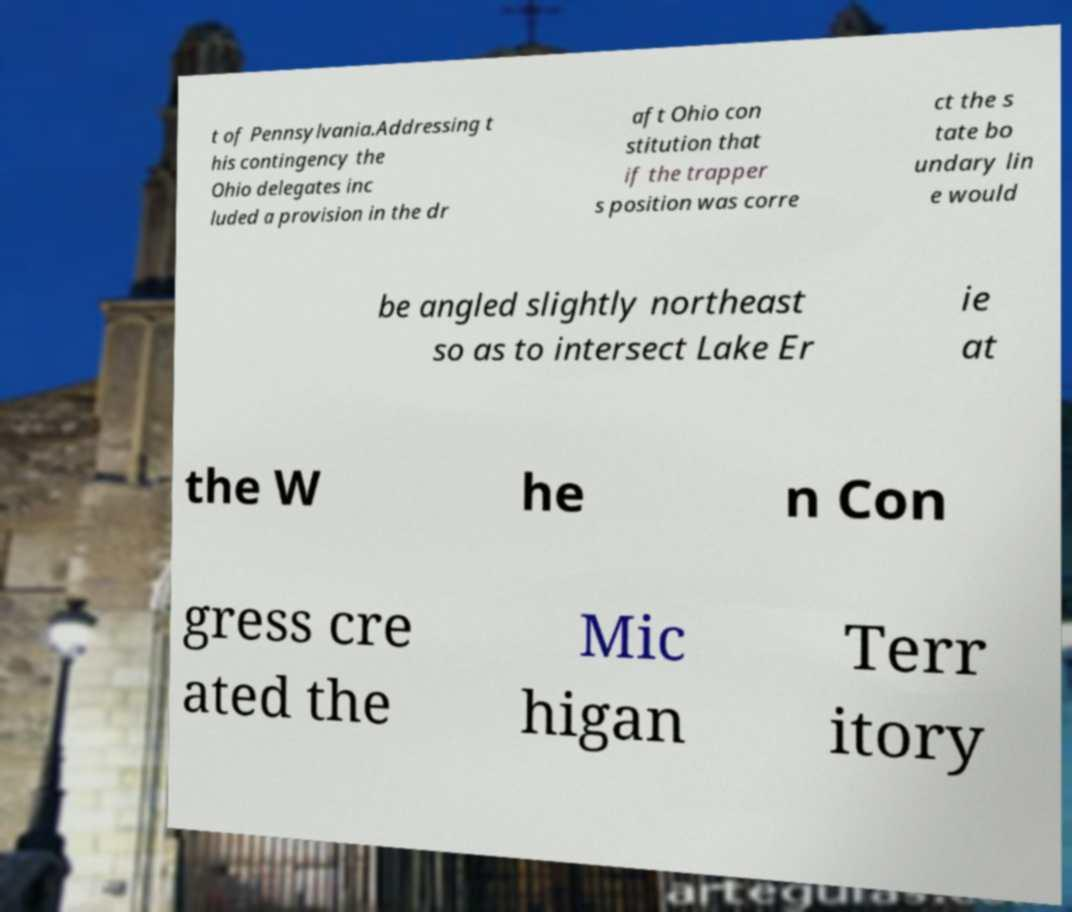Can you read and provide the text displayed in the image?This photo seems to have some interesting text. Can you extract and type it out for me? t of Pennsylvania.Addressing t his contingency the Ohio delegates inc luded a provision in the dr aft Ohio con stitution that if the trapper s position was corre ct the s tate bo undary lin e would be angled slightly northeast so as to intersect Lake Er ie at the W he n Con gress cre ated the Mic higan Terr itory 